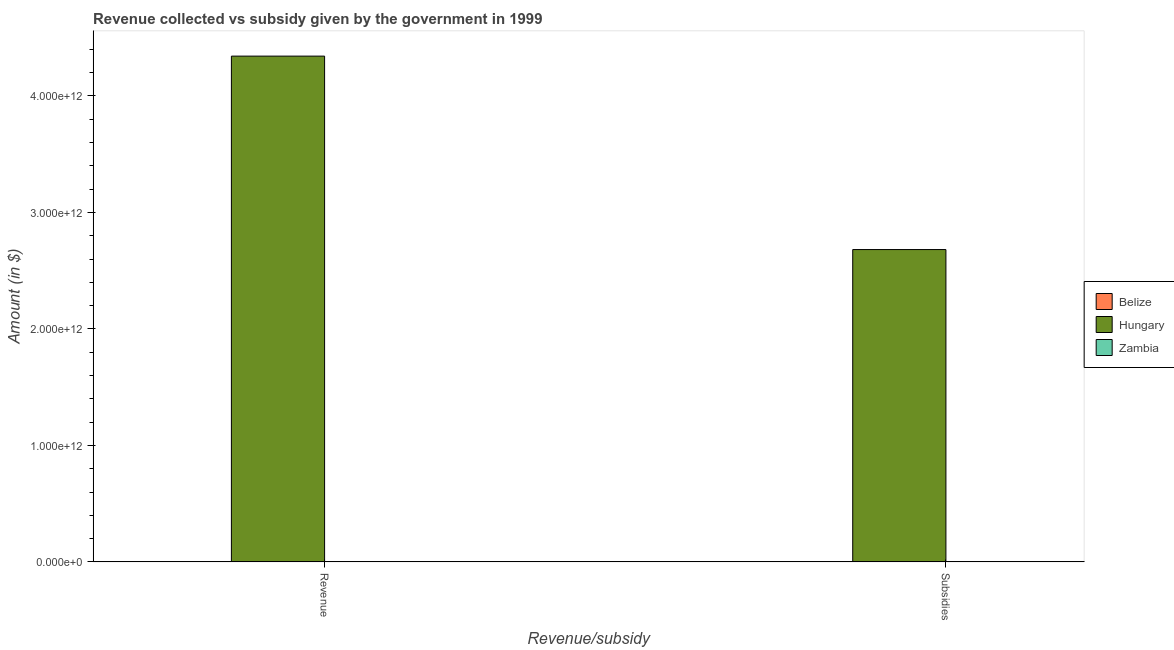How many different coloured bars are there?
Ensure brevity in your answer.  3. Are the number of bars on each tick of the X-axis equal?
Offer a terse response. Yes. What is the label of the 2nd group of bars from the left?
Your answer should be very brief. Subsidies. What is the amount of revenue collected in Zambia?
Give a very brief answer. 1.43e+09. Across all countries, what is the maximum amount of subsidies given?
Provide a short and direct response. 2.68e+12. Across all countries, what is the minimum amount of subsidies given?
Make the answer very short. 5.00e+07. In which country was the amount of subsidies given maximum?
Give a very brief answer. Hungary. In which country was the amount of subsidies given minimum?
Your response must be concise. Belize. What is the total amount of subsidies given in the graph?
Keep it short and to the point. 2.68e+12. What is the difference between the amount of subsidies given in Zambia and that in Belize?
Offer a terse response. 2.12e+08. What is the difference between the amount of subsidies given in Hungary and the amount of revenue collected in Zambia?
Your response must be concise. 2.68e+12. What is the average amount of revenue collected per country?
Provide a short and direct response. 1.45e+12. What is the difference between the amount of subsidies given and amount of revenue collected in Hungary?
Your answer should be compact. -1.66e+12. What is the ratio of the amount of subsidies given in Zambia to that in Belize?
Your answer should be compact. 5.23. In how many countries, is the amount of revenue collected greater than the average amount of revenue collected taken over all countries?
Your response must be concise. 1. What does the 2nd bar from the left in Subsidies represents?
Give a very brief answer. Hungary. What does the 1st bar from the right in Subsidies represents?
Keep it short and to the point. Zambia. Are all the bars in the graph horizontal?
Your answer should be compact. No. How many countries are there in the graph?
Offer a very short reply. 3. What is the difference between two consecutive major ticks on the Y-axis?
Provide a succinct answer. 1.00e+12. Are the values on the major ticks of Y-axis written in scientific E-notation?
Offer a very short reply. Yes. Does the graph contain any zero values?
Your response must be concise. No. Where does the legend appear in the graph?
Offer a terse response. Center right. What is the title of the graph?
Give a very brief answer. Revenue collected vs subsidy given by the government in 1999. What is the label or title of the X-axis?
Your answer should be very brief. Revenue/subsidy. What is the label or title of the Y-axis?
Your answer should be compact. Amount (in $). What is the Amount (in $) of Belize in Revenue?
Your response must be concise. 3.37e+08. What is the Amount (in $) in Hungary in Revenue?
Ensure brevity in your answer.  4.34e+12. What is the Amount (in $) of Zambia in Revenue?
Keep it short and to the point. 1.43e+09. What is the Amount (in $) of Belize in Subsidies?
Ensure brevity in your answer.  5.00e+07. What is the Amount (in $) of Hungary in Subsidies?
Your response must be concise. 2.68e+12. What is the Amount (in $) of Zambia in Subsidies?
Provide a succinct answer. 2.62e+08. Across all Revenue/subsidy, what is the maximum Amount (in $) of Belize?
Offer a terse response. 3.37e+08. Across all Revenue/subsidy, what is the maximum Amount (in $) of Hungary?
Offer a terse response. 4.34e+12. Across all Revenue/subsidy, what is the maximum Amount (in $) in Zambia?
Ensure brevity in your answer.  1.43e+09. Across all Revenue/subsidy, what is the minimum Amount (in $) in Belize?
Keep it short and to the point. 5.00e+07. Across all Revenue/subsidy, what is the minimum Amount (in $) of Hungary?
Ensure brevity in your answer.  2.68e+12. Across all Revenue/subsidy, what is the minimum Amount (in $) of Zambia?
Keep it short and to the point. 2.62e+08. What is the total Amount (in $) in Belize in the graph?
Provide a short and direct response. 3.87e+08. What is the total Amount (in $) in Hungary in the graph?
Your answer should be compact. 7.02e+12. What is the total Amount (in $) in Zambia in the graph?
Offer a very short reply. 1.69e+09. What is the difference between the Amount (in $) of Belize in Revenue and that in Subsidies?
Provide a short and direct response. 2.87e+08. What is the difference between the Amount (in $) of Hungary in Revenue and that in Subsidies?
Make the answer very short. 1.66e+12. What is the difference between the Amount (in $) in Zambia in Revenue and that in Subsidies?
Your response must be concise. 1.17e+09. What is the difference between the Amount (in $) in Belize in Revenue and the Amount (in $) in Hungary in Subsidies?
Offer a very short reply. -2.68e+12. What is the difference between the Amount (in $) in Belize in Revenue and the Amount (in $) in Zambia in Subsidies?
Provide a short and direct response. 7.59e+07. What is the difference between the Amount (in $) of Hungary in Revenue and the Amount (in $) of Zambia in Subsidies?
Offer a very short reply. 4.34e+12. What is the average Amount (in $) in Belize per Revenue/subsidy?
Keep it short and to the point. 1.94e+08. What is the average Amount (in $) in Hungary per Revenue/subsidy?
Your answer should be very brief. 3.51e+12. What is the average Amount (in $) of Zambia per Revenue/subsidy?
Ensure brevity in your answer.  8.46e+08. What is the difference between the Amount (in $) of Belize and Amount (in $) of Hungary in Revenue?
Ensure brevity in your answer.  -4.34e+12. What is the difference between the Amount (in $) in Belize and Amount (in $) in Zambia in Revenue?
Offer a terse response. -1.09e+09. What is the difference between the Amount (in $) of Hungary and Amount (in $) of Zambia in Revenue?
Your answer should be very brief. 4.34e+12. What is the difference between the Amount (in $) in Belize and Amount (in $) in Hungary in Subsidies?
Make the answer very short. -2.68e+12. What is the difference between the Amount (in $) in Belize and Amount (in $) in Zambia in Subsidies?
Provide a succinct answer. -2.12e+08. What is the difference between the Amount (in $) of Hungary and Amount (in $) of Zambia in Subsidies?
Provide a short and direct response. 2.68e+12. What is the ratio of the Amount (in $) in Belize in Revenue to that in Subsidies?
Keep it short and to the point. 6.75. What is the ratio of the Amount (in $) in Hungary in Revenue to that in Subsidies?
Your response must be concise. 1.62. What is the ratio of the Amount (in $) of Zambia in Revenue to that in Subsidies?
Ensure brevity in your answer.  5.47. What is the difference between the highest and the second highest Amount (in $) in Belize?
Give a very brief answer. 2.87e+08. What is the difference between the highest and the second highest Amount (in $) of Hungary?
Provide a succinct answer. 1.66e+12. What is the difference between the highest and the second highest Amount (in $) in Zambia?
Provide a succinct answer. 1.17e+09. What is the difference between the highest and the lowest Amount (in $) in Belize?
Your answer should be very brief. 2.87e+08. What is the difference between the highest and the lowest Amount (in $) of Hungary?
Your response must be concise. 1.66e+12. What is the difference between the highest and the lowest Amount (in $) of Zambia?
Your response must be concise. 1.17e+09. 